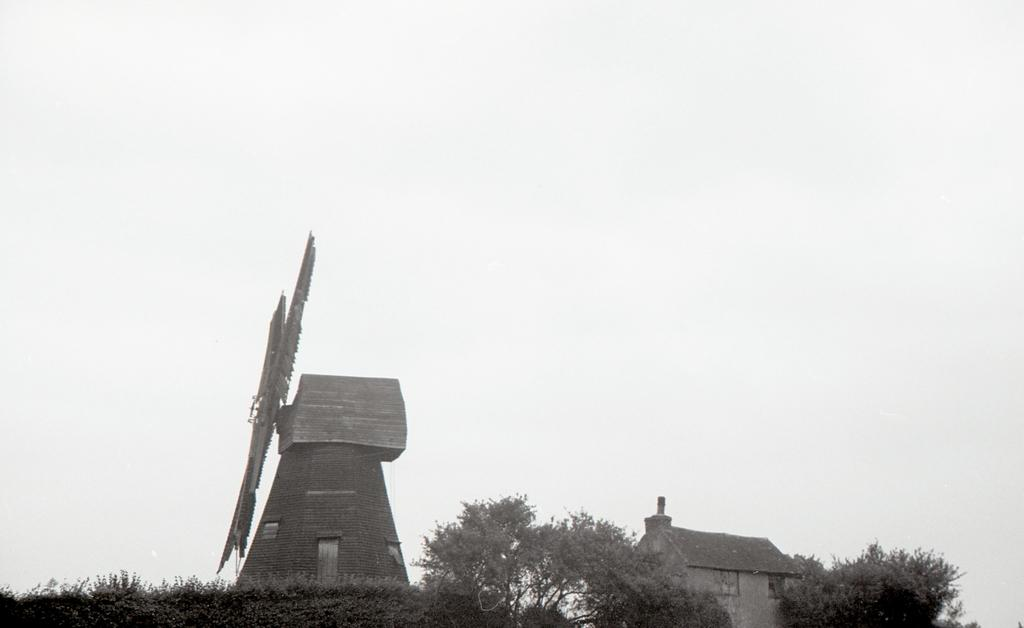What type of natural elements can be seen in the image? There are many trees in the image. What type of structure is present in the image? There is a house in the image. What other man-made object can be seen in the image? There is a windmill in the image. What is visible in the background of the image? The sky is visible in the background of the image. What level of difficulty is the beginner's guide to the windmill in the image? There is no beginner's guide present in the image, as it only features a windmill and other elements. What shape is the scale used to weigh the trees in the image? There is no scale present in the image, and the trees are not being weighed. 